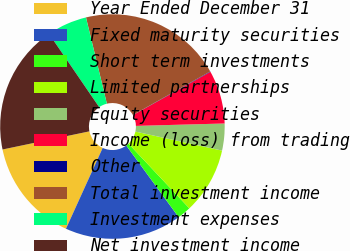<chart> <loc_0><loc_0><loc_500><loc_500><pie_chart><fcel>Year Ended December 31<fcel>Fixed maturity securities<fcel>Short term investments<fcel>Limited partnerships<fcel>Equity securities<fcel>Income (loss) from trading<fcel>Other<fcel>Total investment income<fcel>Investment expenses<fcel>Net investment income<nl><fcel>14.93%<fcel>16.83%<fcel>1.97%<fcel>9.55%<fcel>3.87%<fcel>7.66%<fcel>0.07%<fcel>20.62%<fcel>5.76%<fcel>18.73%<nl></chart> 